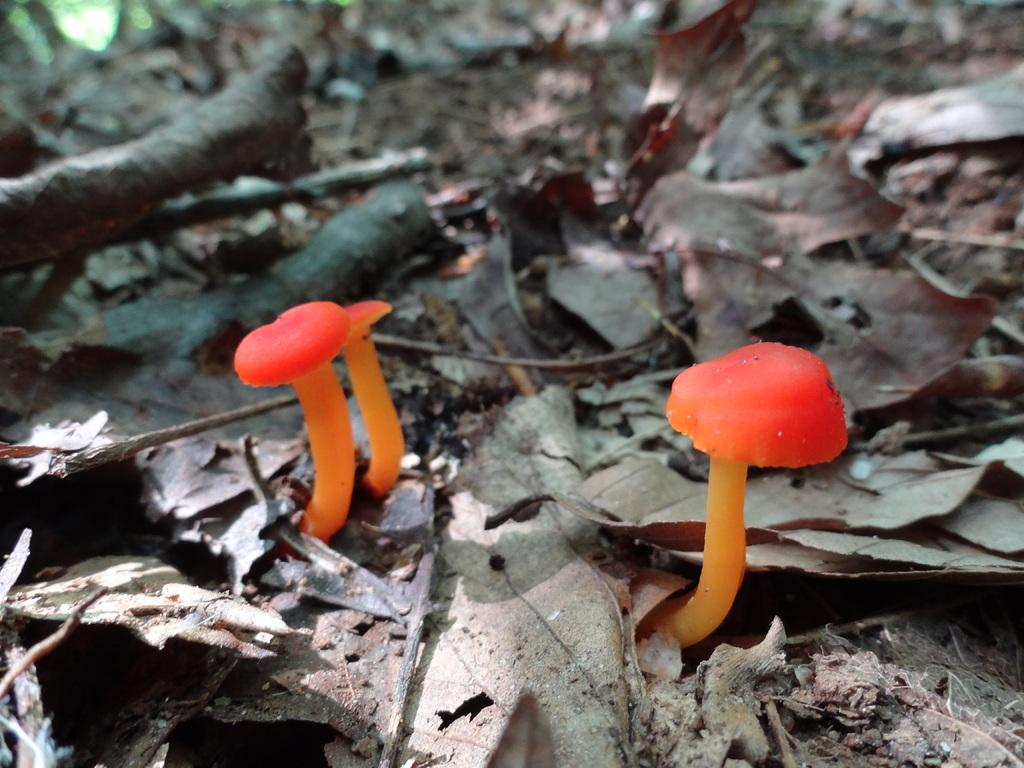How many mushrooms can be seen in the image? There are two mushrooms in the image. Where are the mushrooms located? The mushrooms are on the surface of dry leaves. What is the opinion of the mushrooms about the pot in the image? There is no pot present in the image, and mushrooms do not have opinions. 